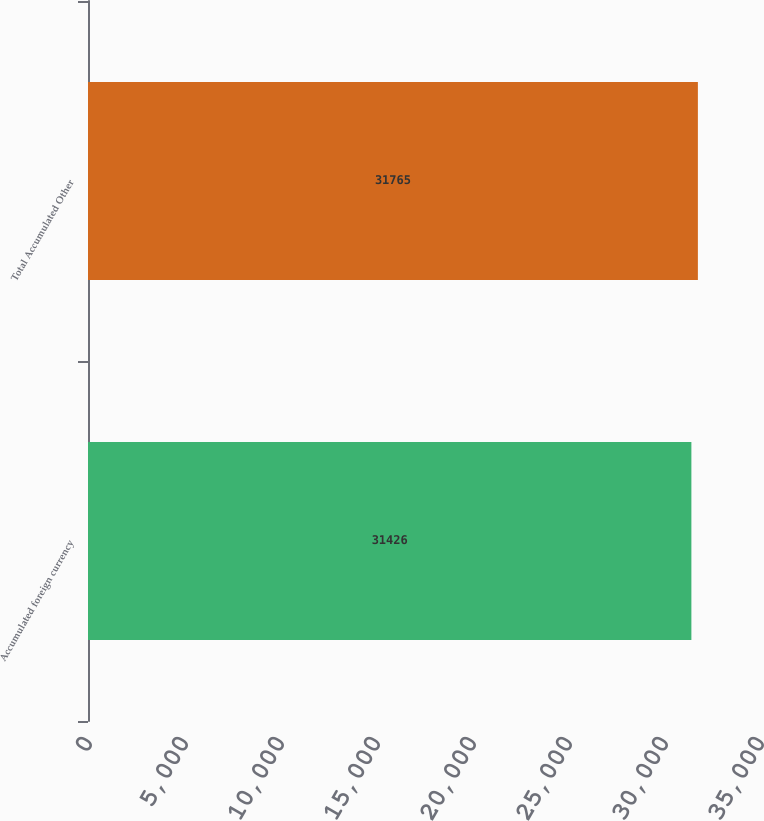Convert chart. <chart><loc_0><loc_0><loc_500><loc_500><bar_chart><fcel>Accumulated foreign currency<fcel>Total Accumulated Other<nl><fcel>31426<fcel>31765<nl></chart> 